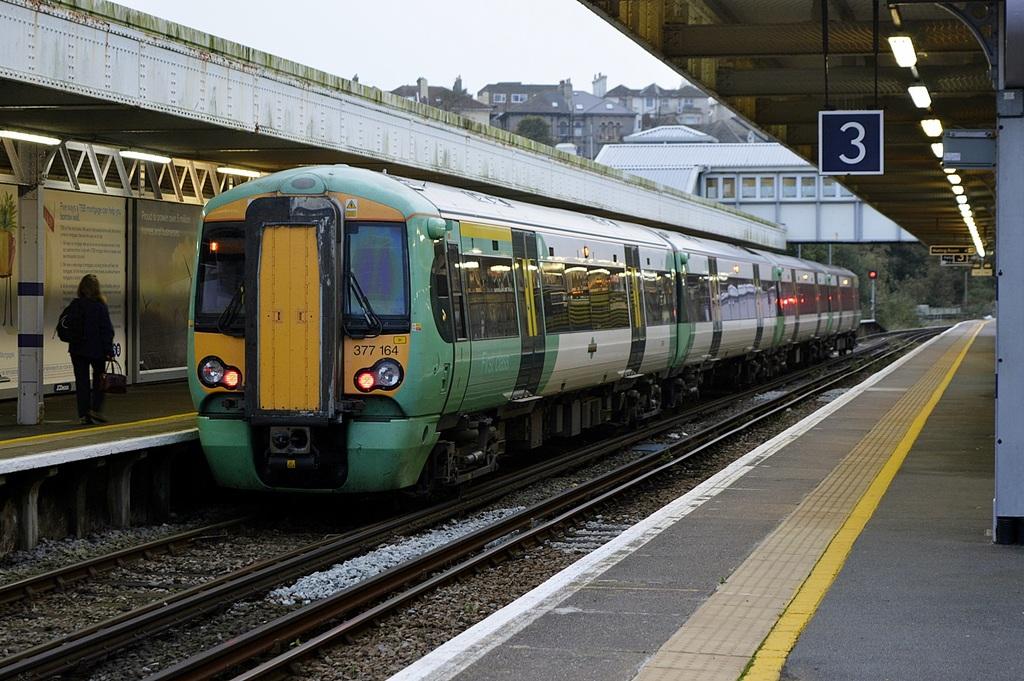What train station is this?
Provide a short and direct response. 3. 